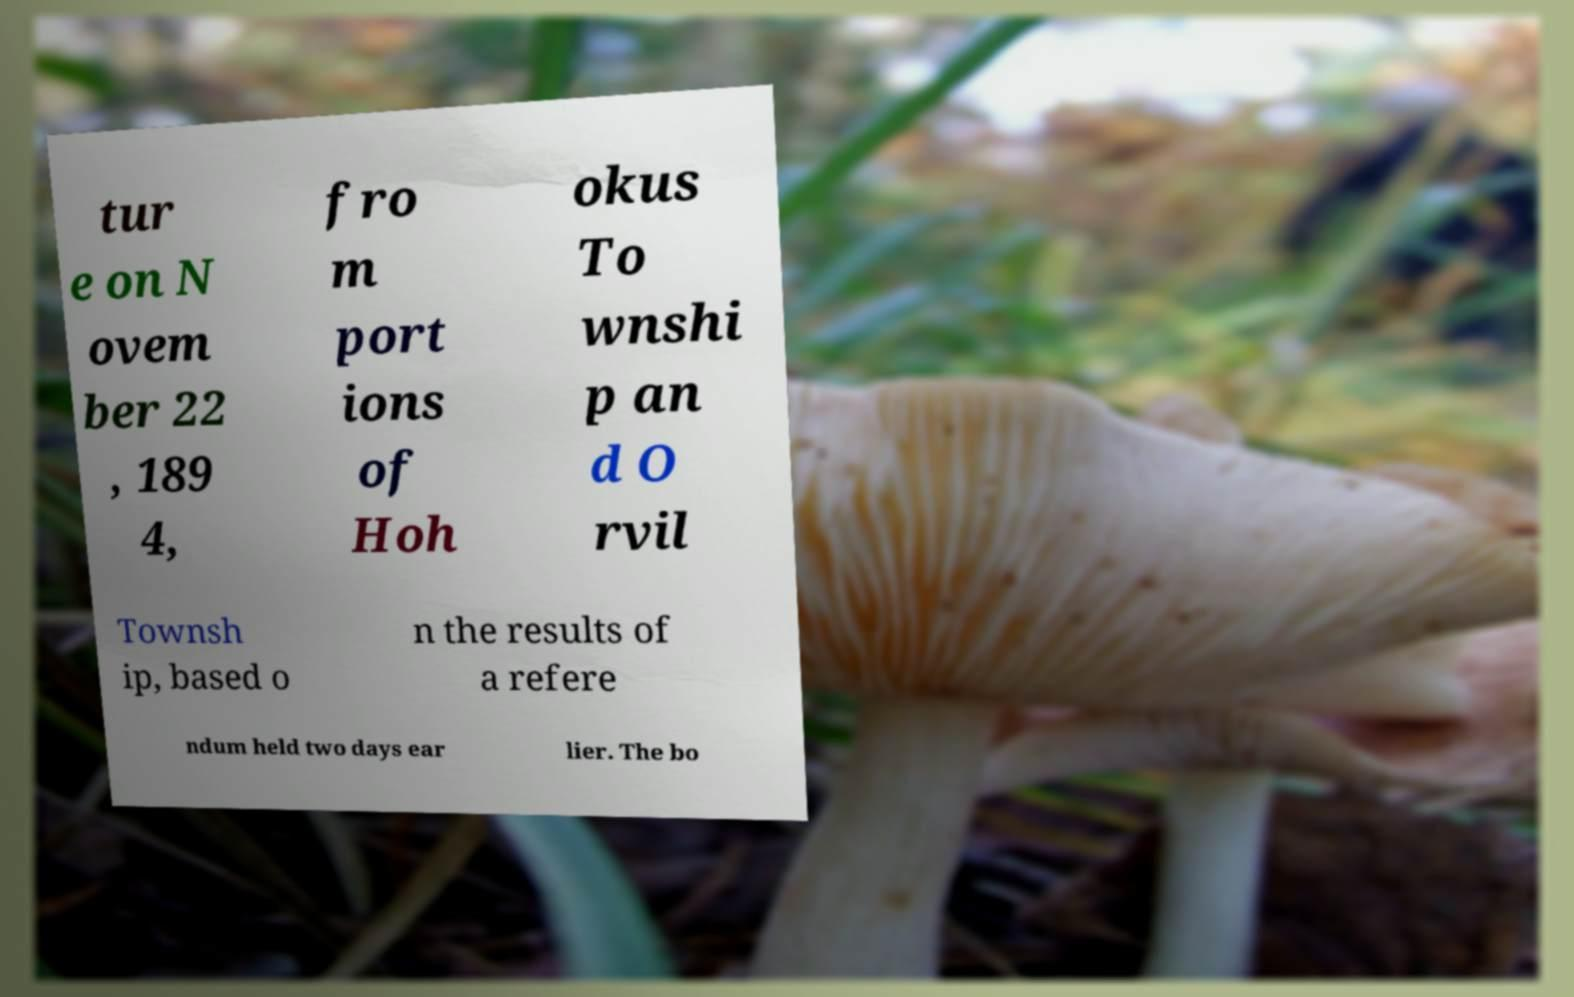Can you accurately transcribe the text from the provided image for me? tur e on N ovem ber 22 , 189 4, fro m port ions of Hoh okus To wnshi p an d O rvil Townsh ip, based o n the results of a refere ndum held two days ear lier. The bo 